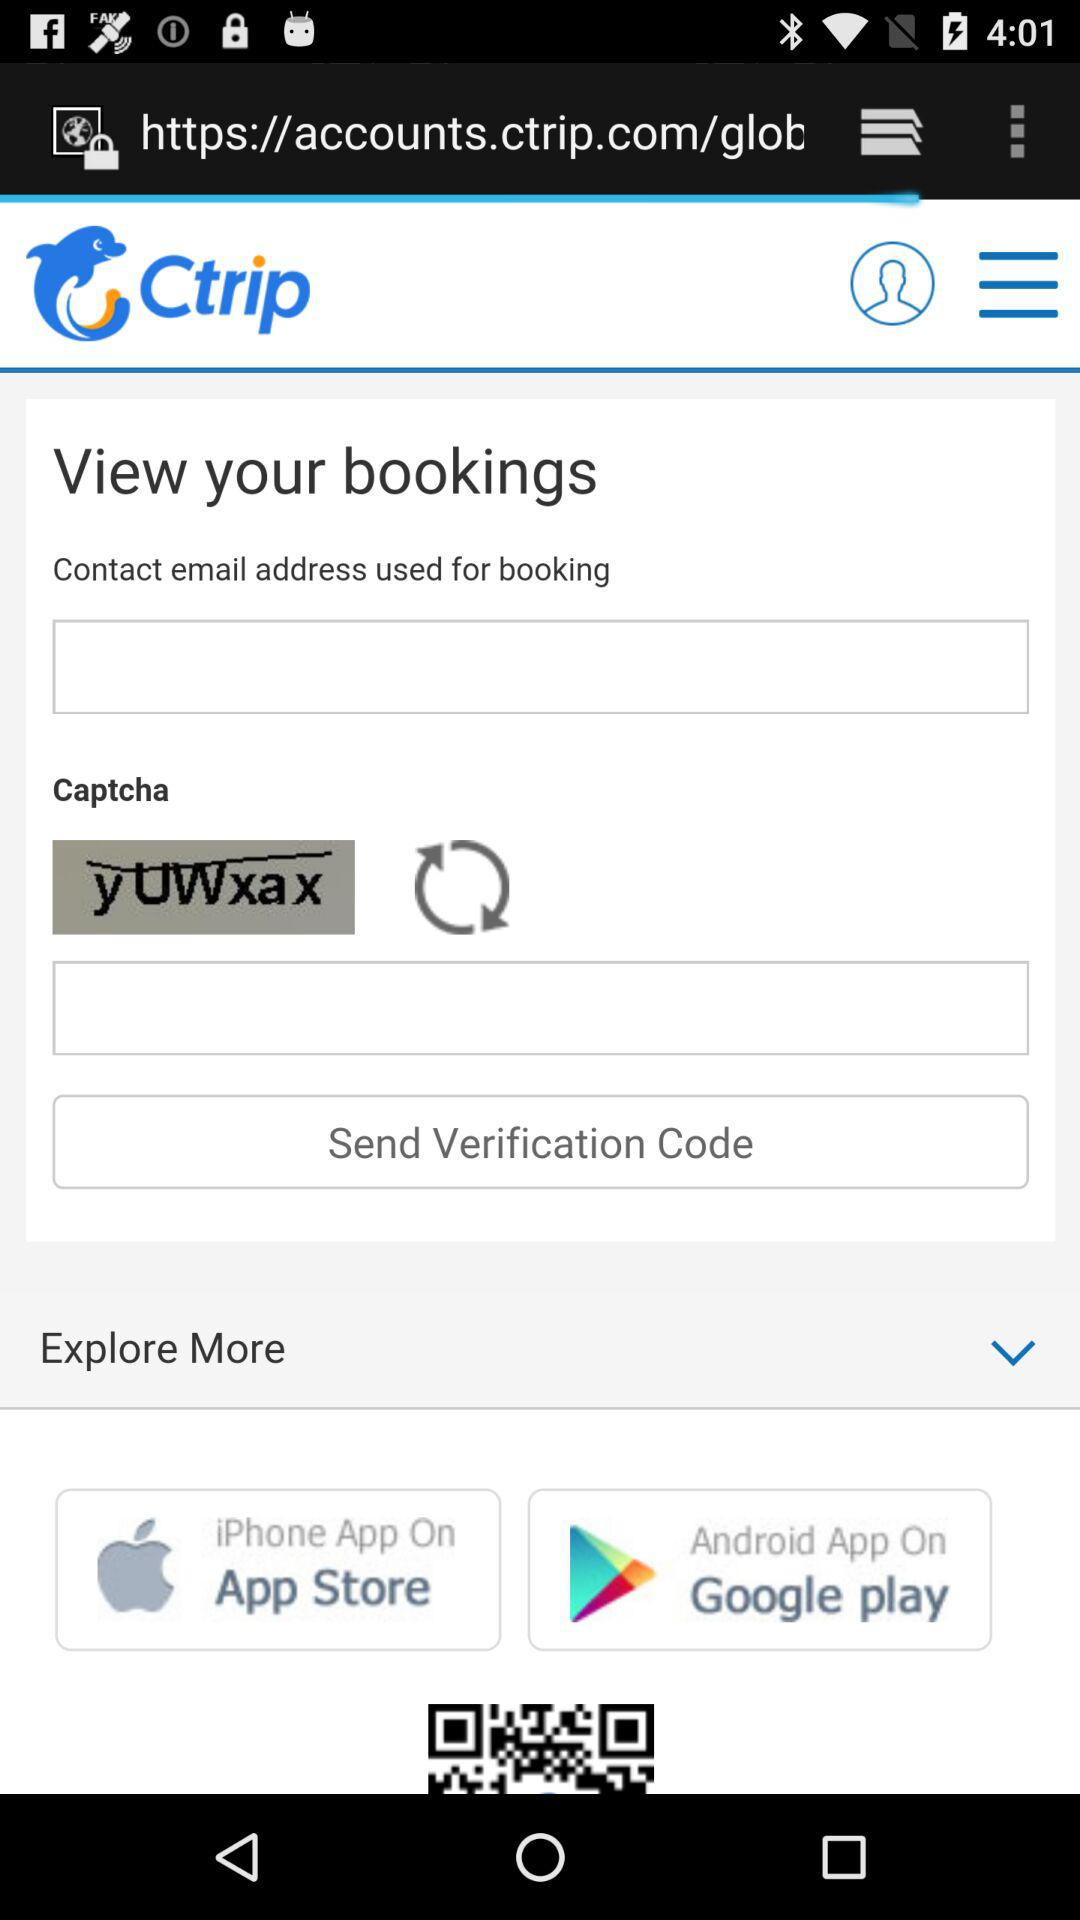What is the name of the application? The name of the application is "Ctrip". 